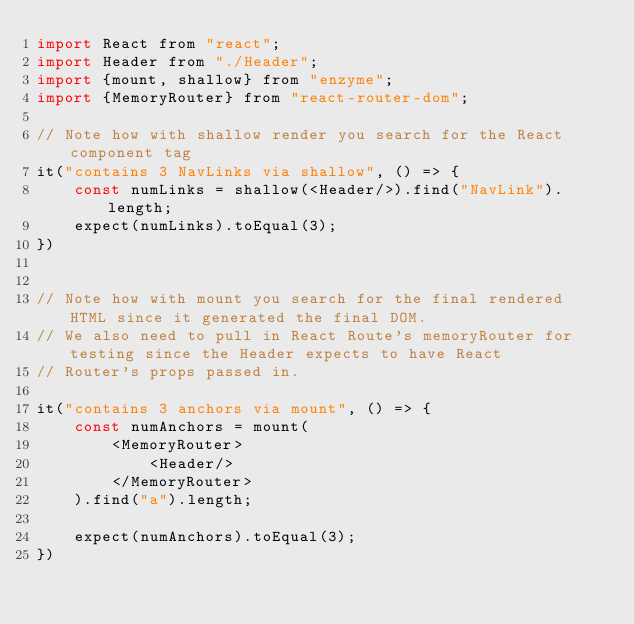Convert code to text. <code><loc_0><loc_0><loc_500><loc_500><_JavaScript_>import React from "react";
import Header from "./Header";
import {mount, shallow} from "enzyme";
import {MemoryRouter} from "react-router-dom";

// Note how with shallow render you search for the React component tag
it("contains 3 NavLinks via shallow", () => {
    const numLinks = shallow(<Header/>).find("NavLink").length;
    expect(numLinks).toEqual(3);
})


// Note how with mount you search for the final rendered HTML since it generated the final DOM.
// We also need to pull in React Route's memoryRouter for testing since the Header expects to have React
// Router's props passed in.

it("contains 3 anchors via mount", () => {
    const numAnchors = mount(
        <MemoryRouter>
            <Header/>
        </MemoryRouter>
    ).find("a").length;

    expect(numAnchors).toEqual(3);
})</code> 